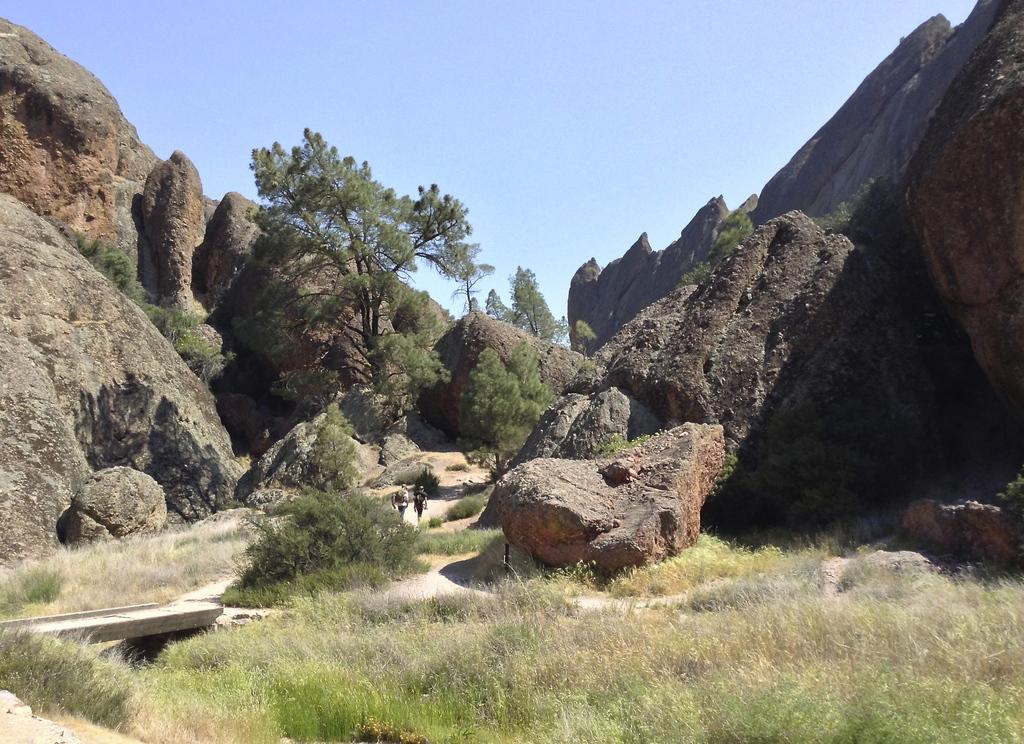What are the two persons in the image doing? The two persons in the image are walking. What type of vegetation can be seen in the image? There are trees in the image. What is the color of the trees? The trees are green. What can be seen in the background of the image? There are rocks in the background of the image. What is the color of the sky in the image? The sky is blue and white in color. Can you tell me how many robins are perched on the trees in the image? There are no robins present in the image; only trees and rocks can be seen in the background. 